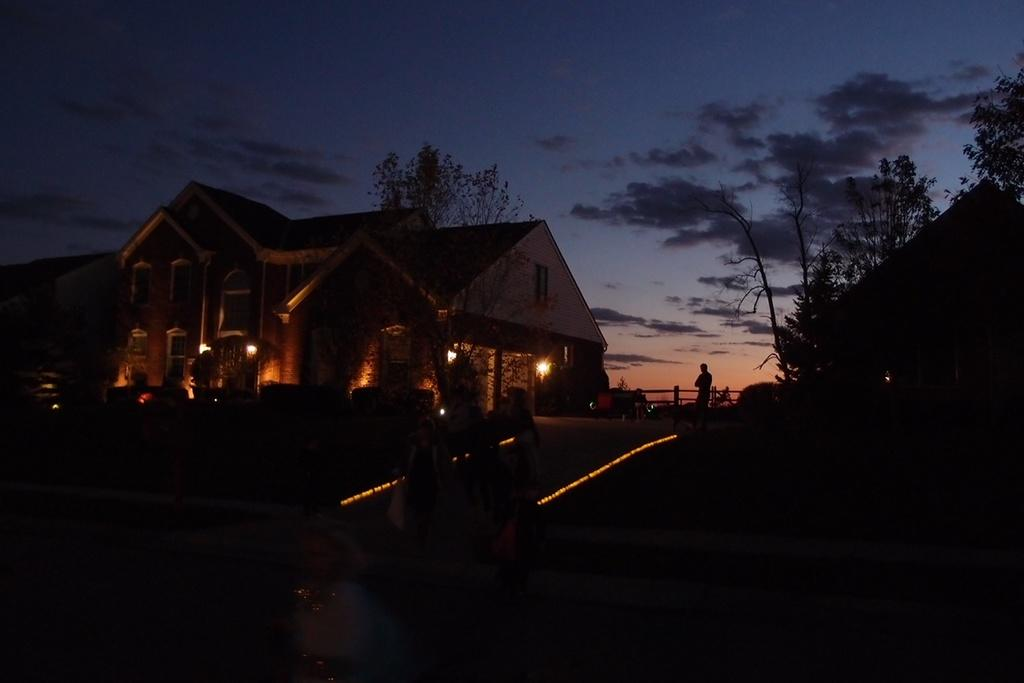What type of structure is present in the image? There is a building in the image. What feature can be observed on the building? The building has windows. Can you describe the lighting in the image? There is a light in the image. What is the person in the image doing? A person is standing in the image. What type of vegetation is present in the image? There are trees in the image. What type of path is visible in the image? There is a footpath in the image. What part of the natural environment is visible in the image? The sky is visible in the image. What type of water feature is present in the image? There is water in the image. What type of bag is being used to shock the person in the image? There is no bag or shocking activity present in the image. What type of cemetery can be seen in the image? There is no cemetery present in the image. 